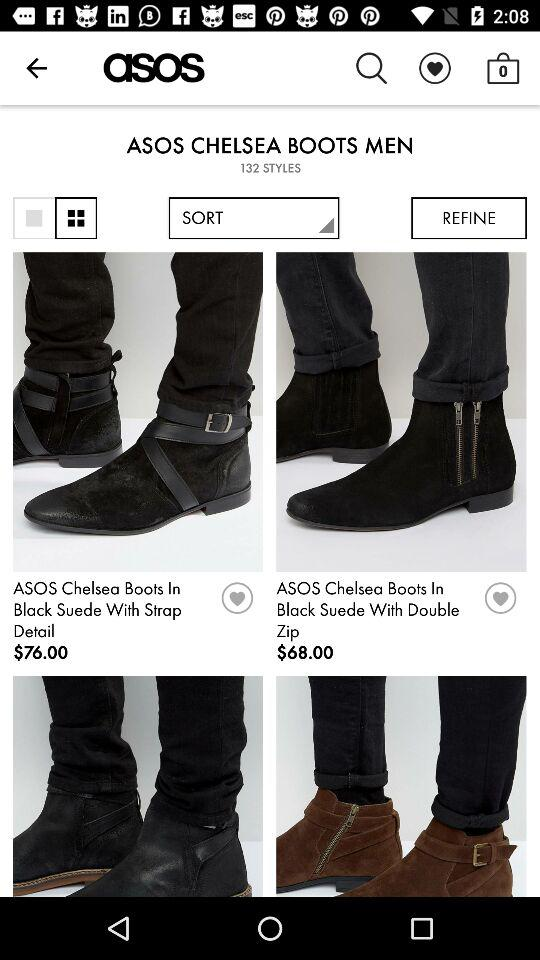How many boot styles are available? There are 132 boot styles available. 